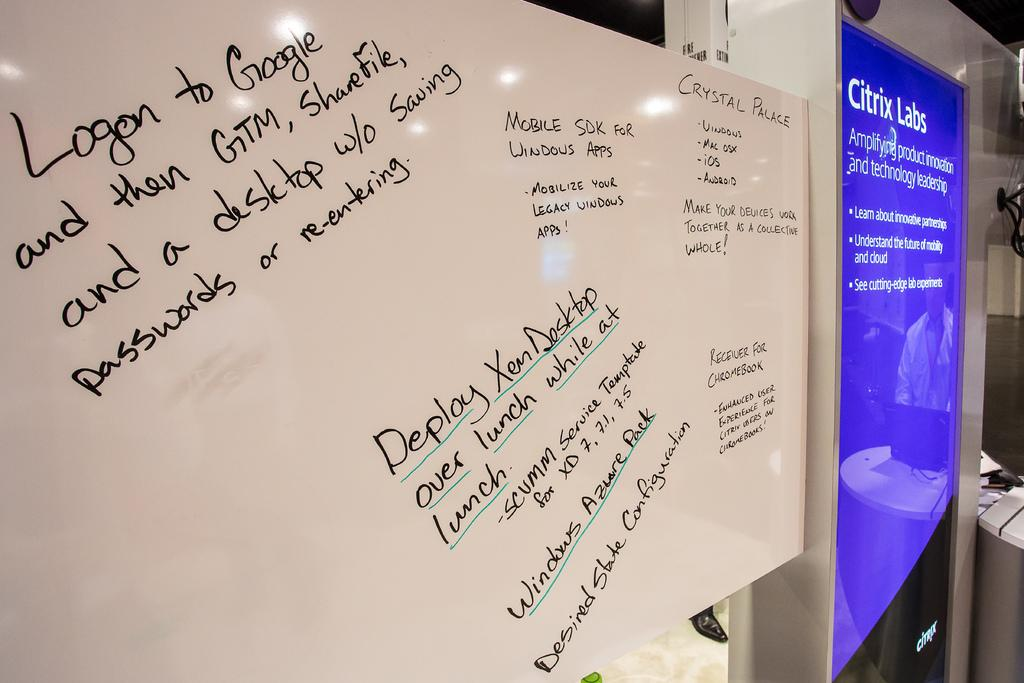What can be seen on the boards in the image? There are boards with text in the image. Can you describe the reflection in the image? There is a reflection of a person in the image. What type of furniture is present in the image? There is a table in the image. What electronic device is on the table? A laptop is present on the table. Where is the cart located in the image? There is no cart present in the image. What type of print can be seen on the laptop's screen? There is no print visible on the laptop's screen in the image. 